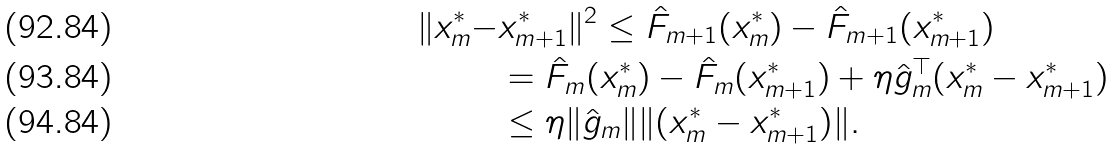<formula> <loc_0><loc_0><loc_500><loc_500>\| x _ { m } ^ { * } - & x _ { m + 1 } ^ { * } \| ^ { 2 } \leq \hat { F } _ { m + 1 } ( x _ { m } ^ { * } ) - \hat { F } _ { m + 1 } ( x _ { m + 1 } ^ { * } ) \\ & = \hat { F } _ { m } ( x _ { m } ^ { * } ) - \hat { F } _ { m } ( x _ { m + 1 } ^ { * } ) + \eta \hat { g } _ { m } ^ { \top } ( x _ { m } ^ { * } - x _ { m + 1 } ^ { * } ) \\ & \leq \eta \| \hat { g } _ { m } \| \| ( x _ { m } ^ { * } - x _ { m + 1 } ^ { * } ) \| .</formula> 